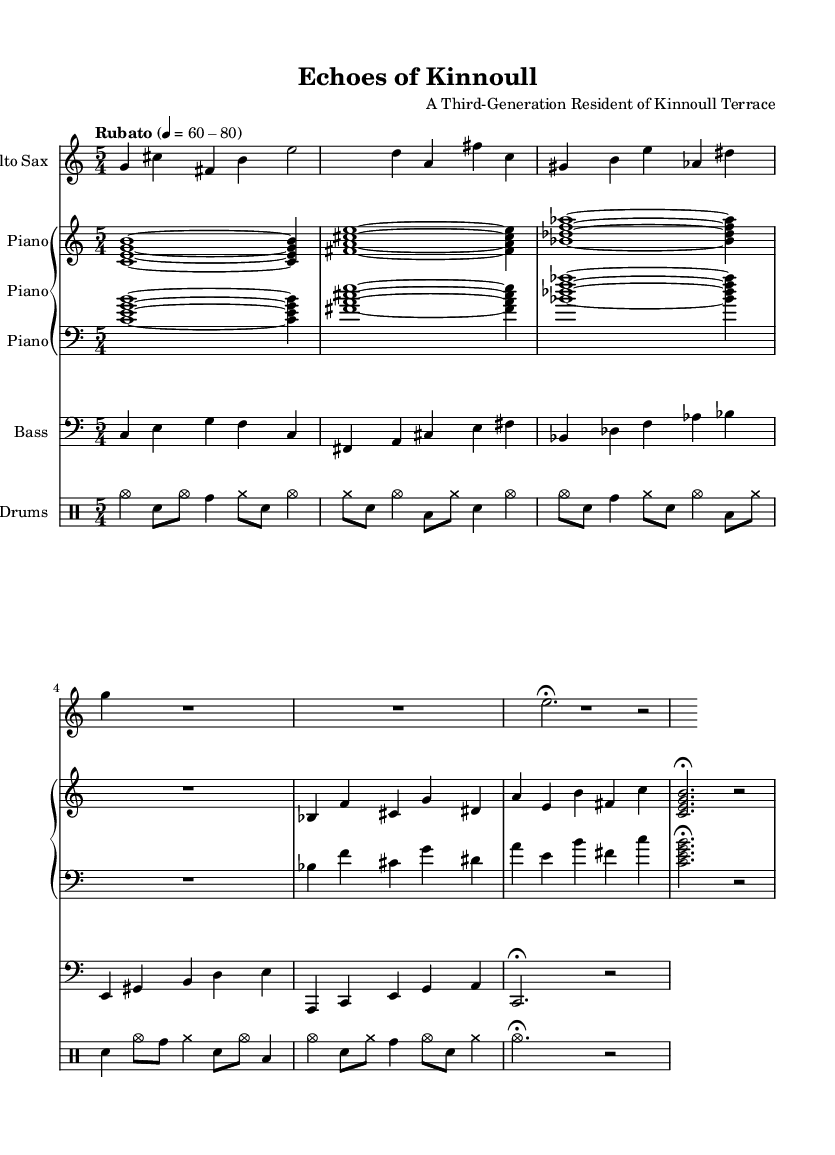What is the time signature of this music? The time signature, indicated at the beginning of the score, is 5/4. This means there are five beats in each measure.
Answer: 5/4 What is the tempo marking for the piece? The tempo marking appears at the beginning and indicates "Rubato" with a range of 60-80 beats per minute. This suggests a flexible tempo approach typical in jazz.
Answer: Rubato Which instrument plays the introduction? The introduction is written for the alto saxophone, as indicated at the start of that staff.
Answer: Alto Sax How many measures are in the Coda section of the piece? By counting the measures from the Coda section, which consists of the final lines for each instrument, there are 2 measures.
Answer: 2 What style of jazz does this composition represent? This composition, with its elements of improvisation, irregular rhythms, and complex harmonies, represents avant-garde jazz influences. This is clear from the structure and instruction for improvisation.
Answer: Avant-garde jazz What is the primary musical texture featured in this piece? The primary musical texture is polyphonic, as multiple voices (saxophone, piano, bass, drums) interact and create distinct lines that contribute to the overall sound.
Answer: Polyphonic 